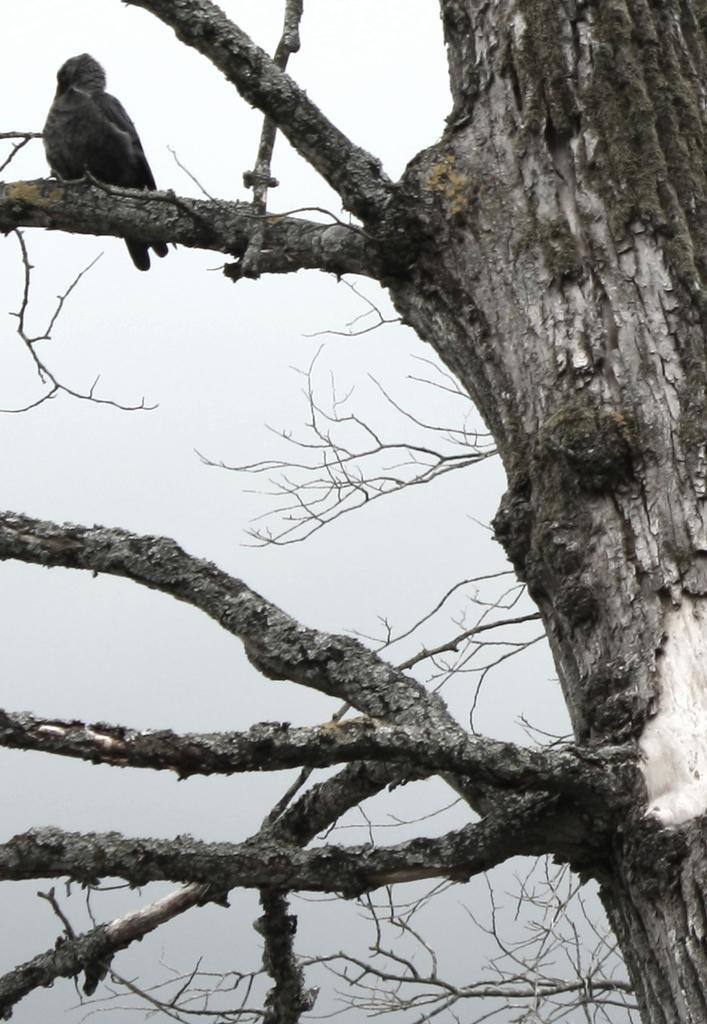Please provide a concise description of this image. In the image we can see there is a dry tree and there is a bird sitting on the dry tree. There is a clear sky on the top. 